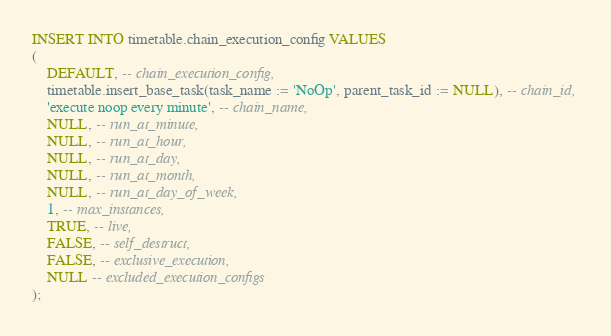Convert code to text. <code><loc_0><loc_0><loc_500><loc_500><_SQL_>INSERT INTO timetable.chain_execution_config VALUES 
(
    DEFAULT, -- chain_execution_config, 
    timetable.insert_base_task(task_name := 'NoOp', parent_task_id := NULL), -- chain_id, 
    'execute noop every minute', -- chain_name, 
    NULL, -- run_at_minute, 
    NULL, -- run_at_hour, 
    NULL, -- run_at_day, 
    NULL, -- run_at_month,
    NULL, -- run_at_day_of_week, 
    1, -- max_instances, 
    TRUE, -- live, 
    FALSE, -- self_destruct,
	FALSE, -- exclusive_execution, 
    NULL -- excluded_execution_configs
);</code> 